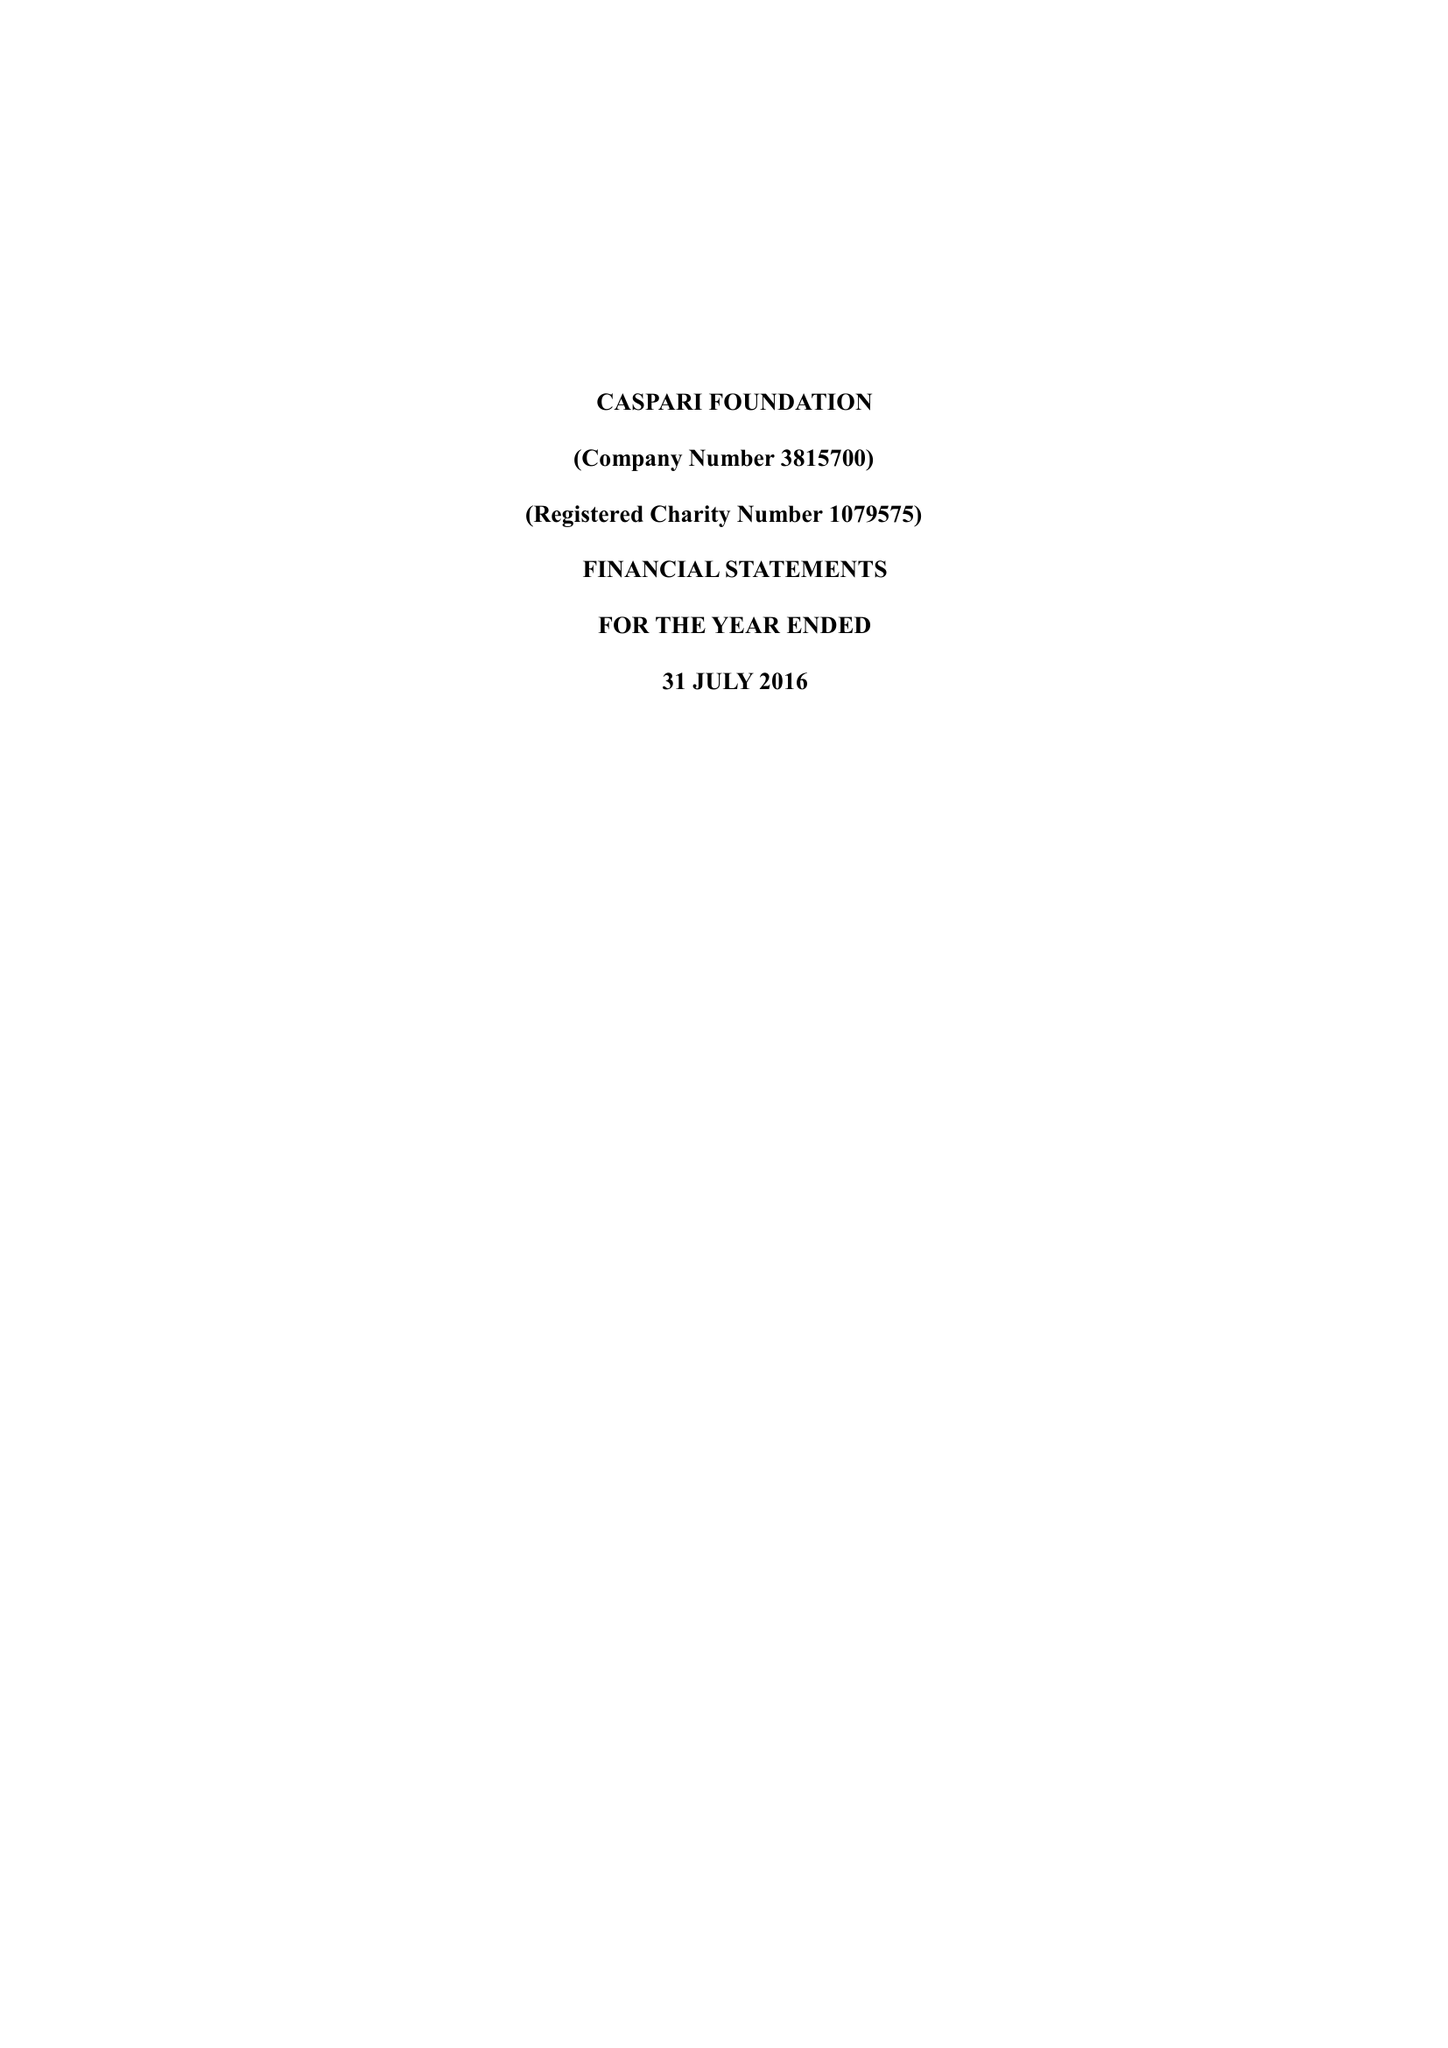What is the value for the address__postcode?
Answer the question using a single word or phrase. N4 2DA 